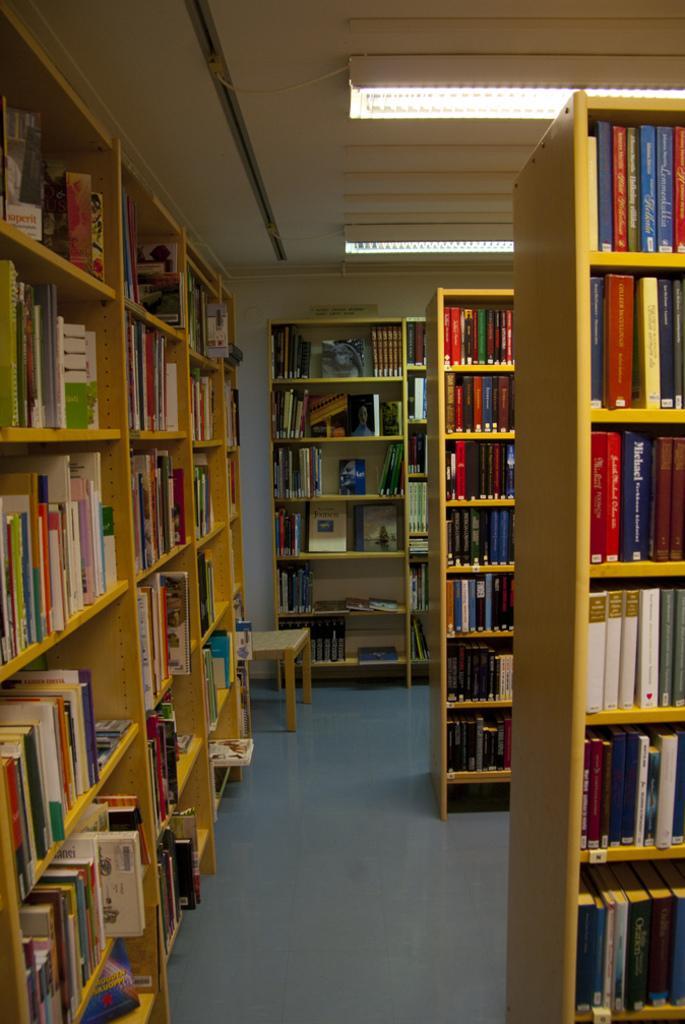Describe this image in one or two sentences. In this picture we can see inside view of the library. In the front we can see some books in the wooden rack. 